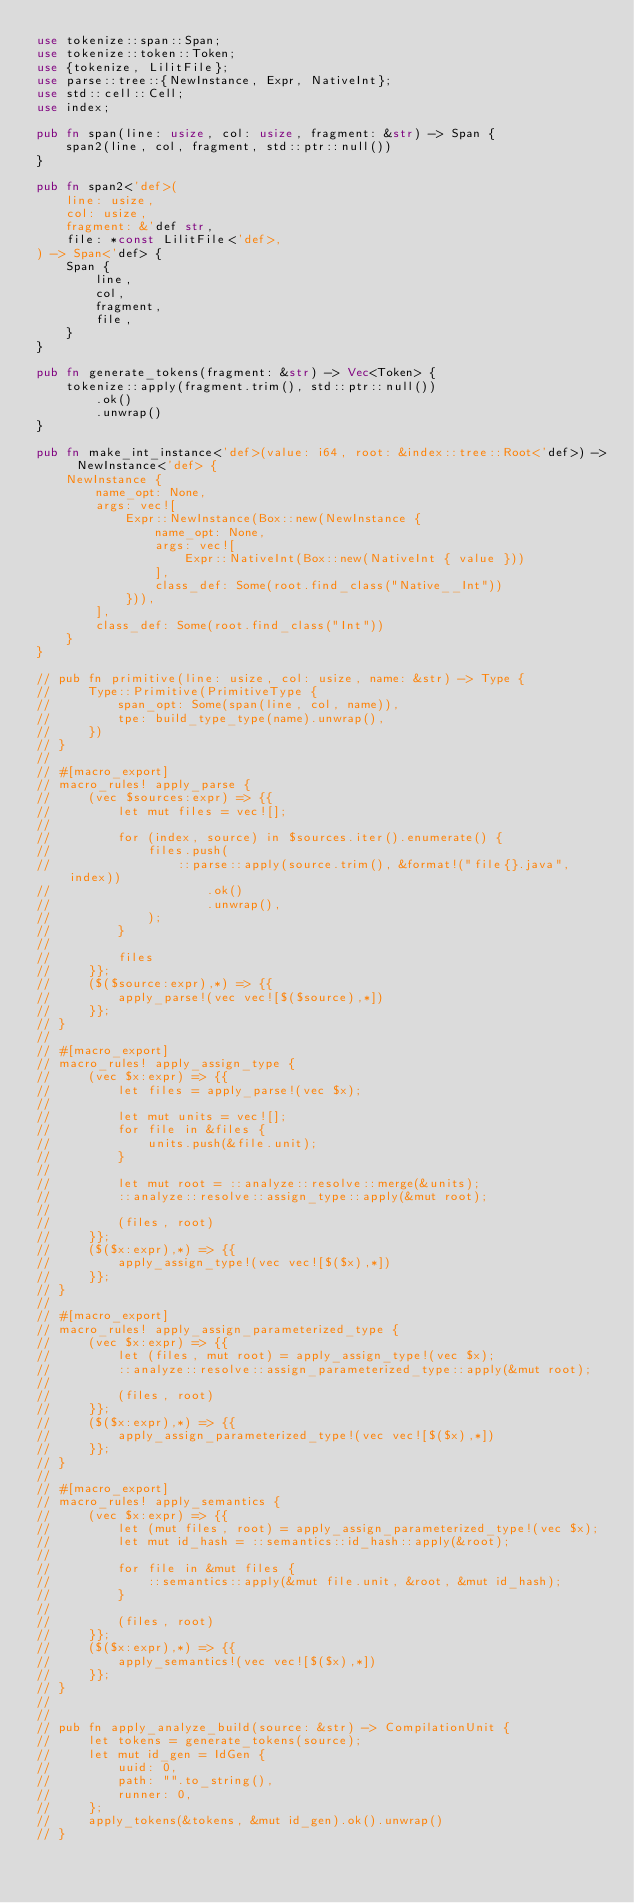<code> <loc_0><loc_0><loc_500><loc_500><_Rust_>use tokenize::span::Span;
use tokenize::token::Token;
use {tokenize, LilitFile};
use parse::tree::{NewInstance, Expr, NativeInt};
use std::cell::Cell;
use index;

pub fn span(line: usize, col: usize, fragment: &str) -> Span {
    span2(line, col, fragment, std::ptr::null())
}

pub fn span2<'def>(
    line: usize,
    col: usize,
    fragment: &'def str,
    file: *const LilitFile<'def>,
) -> Span<'def> {
    Span {
        line,
        col,
        fragment,
        file,
    }
}

pub fn generate_tokens(fragment: &str) -> Vec<Token> {
    tokenize::apply(fragment.trim(), std::ptr::null())
        .ok()
        .unwrap()
}

pub fn make_int_instance<'def>(value: i64, root: &index::tree::Root<'def>) -> NewInstance<'def> {
    NewInstance {
        name_opt: None,
        args: vec![
            Expr::NewInstance(Box::new(NewInstance {
                name_opt: None,
                args: vec![
                    Expr::NativeInt(Box::new(NativeInt { value }))
                ],
                class_def: Some(root.find_class("Native__Int"))
            })),
        ],
        class_def: Some(root.find_class("Int"))
    }
}

// pub fn primitive(line: usize, col: usize, name: &str) -> Type {
//     Type::Primitive(PrimitiveType {
//         span_opt: Some(span(line, col, name)),
//         tpe: build_type_type(name).unwrap(),
//     })
// }
//
// #[macro_export]
// macro_rules! apply_parse {
//     (vec $sources:expr) => {{
//         let mut files = vec![];
//
//         for (index, source) in $sources.iter().enumerate() {
//             files.push(
//                 ::parse::apply(source.trim(), &format!("file{}.java", index))
//                     .ok()
//                     .unwrap(),
//             );
//         }
//
//         files
//     }};
//     ($($source:expr),*) => {{
//         apply_parse!(vec vec![$($source),*])
//     }};
// }
//
// #[macro_export]
// macro_rules! apply_assign_type {
//     (vec $x:expr) => {{
//         let files = apply_parse!(vec $x);
//
//         let mut units = vec![];
//         for file in &files {
//             units.push(&file.unit);
//         }
//
//         let mut root = ::analyze::resolve::merge(&units);
//         ::analyze::resolve::assign_type::apply(&mut root);
//
//         (files, root)
//     }};
//     ($($x:expr),*) => {{
//         apply_assign_type!(vec vec![$($x),*])
//     }};
// }
//
// #[macro_export]
// macro_rules! apply_assign_parameterized_type {
//     (vec $x:expr) => {{
//         let (files, mut root) = apply_assign_type!(vec $x);
//         ::analyze::resolve::assign_parameterized_type::apply(&mut root);
//
//         (files, root)
//     }};
//     ($($x:expr),*) => {{
//         apply_assign_parameterized_type!(vec vec![$($x),*])
//     }};
// }
//
// #[macro_export]
// macro_rules! apply_semantics {
//     (vec $x:expr) => {{
//         let (mut files, root) = apply_assign_parameterized_type!(vec $x);
//         let mut id_hash = ::semantics::id_hash::apply(&root);
//
//         for file in &mut files {
//             ::semantics::apply(&mut file.unit, &root, &mut id_hash);
//         }
//
//         (files, root)
//     }};
//     ($($x:expr),*) => {{
//         apply_semantics!(vec vec![$($x),*])
//     }};
// }
//
//
// pub fn apply_analyze_build(source: &str) -> CompilationUnit {
//     let tokens = generate_tokens(source);
//     let mut id_gen = IdGen {
//         uuid: 0,
//         path: "".to_string(),
//         runner: 0,
//     };
//     apply_tokens(&tokens, &mut id_gen).ok().unwrap()
// }</code> 